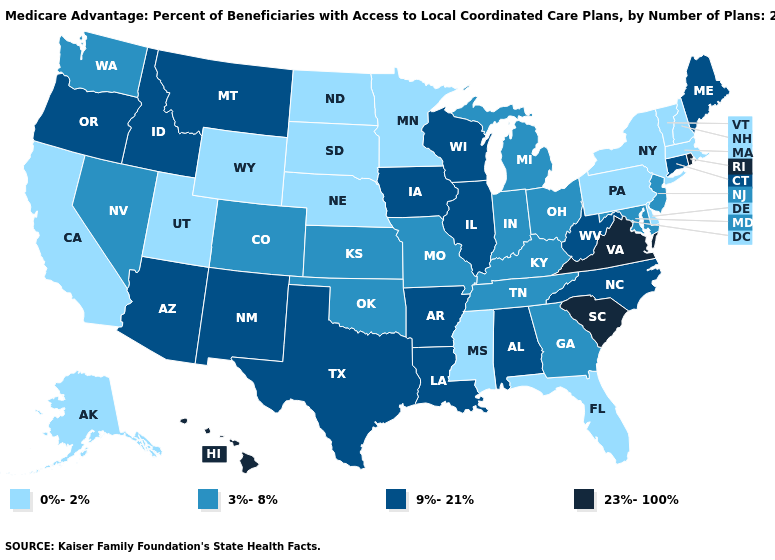Among the states that border Michigan , which have the lowest value?
Write a very short answer. Indiana, Ohio. Does Oregon have a higher value than New York?
Concise answer only. Yes. Name the states that have a value in the range 0%-2%?
Be succinct. Alaska, California, Delaware, Florida, Massachusetts, Minnesota, Mississippi, North Dakota, Nebraska, New Hampshire, New York, Pennsylvania, South Dakota, Utah, Vermont, Wyoming. Name the states that have a value in the range 0%-2%?
Quick response, please. Alaska, California, Delaware, Florida, Massachusetts, Minnesota, Mississippi, North Dakota, Nebraska, New Hampshire, New York, Pennsylvania, South Dakota, Utah, Vermont, Wyoming. Does Oklahoma have a higher value than Connecticut?
Answer briefly. No. Among the states that border Tennessee , does Virginia have the highest value?
Answer briefly. Yes. Does Tennessee have the highest value in the USA?
Be succinct. No. What is the value of Alabama?
Write a very short answer. 9%-21%. What is the highest value in states that border New Hampshire?
Write a very short answer. 9%-21%. What is the lowest value in the USA?
Keep it brief. 0%-2%. What is the lowest value in the USA?
Quick response, please. 0%-2%. What is the highest value in states that border Mississippi?
Answer briefly. 9%-21%. What is the value of Nebraska?
Write a very short answer. 0%-2%. What is the lowest value in states that border Wisconsin?
Quick response, please. 0%-2%. Among the states that border Nevada , which have the lowest value?
Write a very short answer. California, Utah. 